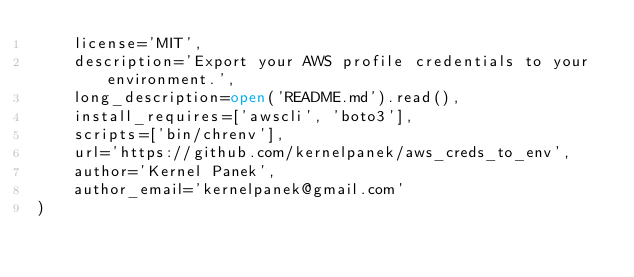Convert code to text. <code><loc_0><loc_0><loc_500><loc_500><_Python_>    license='MIT',
    description='Export your AWS profile credentials to your environment.',
    long_description=open('README.md').read(),
    install_requires=['awscli', 'boto3'],
    scripts=['bin/chrenv'],
    url='https://github.com/kernelpanek/aws_creds_to_env',
    author='Kernel Panek',
    author_email='kernelpanek@gmail.com'
)
</code> 